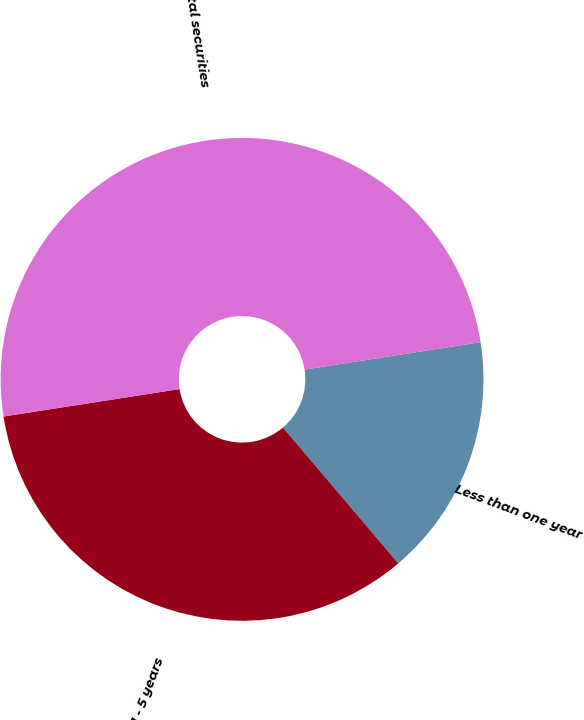Convert chart. <chart><loc_0><loc_0><loc_500><loc_500><pie_chart><fcel>Less than one year<fcel>Due in 1 - 5 years<fcel>Total securities<nl><fcel>16.26%<fcel>33.74%<fcel>50.0%<nl></chart> 